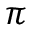<formula> <loc_0><loc_0><loc_500><loc_500>\pi</formula> 